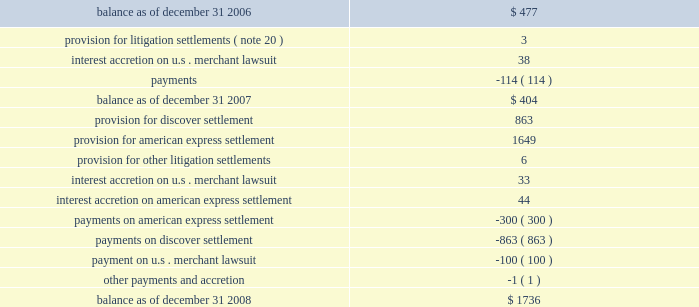We recorded liabilities for certain litigation settlements in prior periods .
Total liabilities for litigation settlements changed from december 31 , 2006 , as follows : ( in millions ) .
* note that table may not sum due to rounding .
Contribution expense 2014foundation in may 2006 , in conjunction with our initial public offering ( 201cipo 201d ) , we issued 13496933 shares of our class a common stock as a donation to the foundation that is incorporated in canada and controlled by directors who are independent of us and our customers .
The foundation builds on mastercard 2019s existing charitable giving commitments by continuing to support programs and initiatives that help children and youth to access education , understand and utilize technology , and develop the skills necessary to succeed in a diverse and global work force .
The vision of the foundation is to make the economy work for everybody by advancing innovative programs in areas of microfinance and youth education .
In connection with the donation of the class a common stock , we recorded an expense of $ 395 million which was equal to the aggregate value of the shares we donated .
In both 2007 and 2006 , we recorded expenses of $ 20 million for cash donations we made to the foundation , completing our intention , announced at the time of the ipo , to donate approximately $ 40 million in cash to the foundation in support of its operating expenses and charitable disbursements for the first four years of its operations .
We may make additional cash contributions to the foundation in the future .
The cash and stock donations to the foundation are generally not deductible by mastercard for tax purposes .
As a result of this difference between the financial statement and tax treatments of the donations , our effective income tax rate for the year ended december 31 , 2006 is significantly higher than our effective income tax rates for 2007 and 2008 .
Depreciation and amortization depreciation and amortization expenses increased $ 14 million in 2008 and decreased $ 2 million in 2007 .
The increase in depreciation and amortization expense in 2008 is primarily due to increased investments in leasehold and building improvements , data center equipment and capitalized software .
The decrease in depreciation and amortization expense in 2007 was primarily related to certain assets becoming fully depreciated .
Depreciation and amortization will increase as we continue to invest in leasehold and building improvements , data center equipment and capitalized software. .
What is the net change in the balance of total liabilities for litigation settlements during 2007? 
Computations: (404 - 477)
Answer: -73.0. 